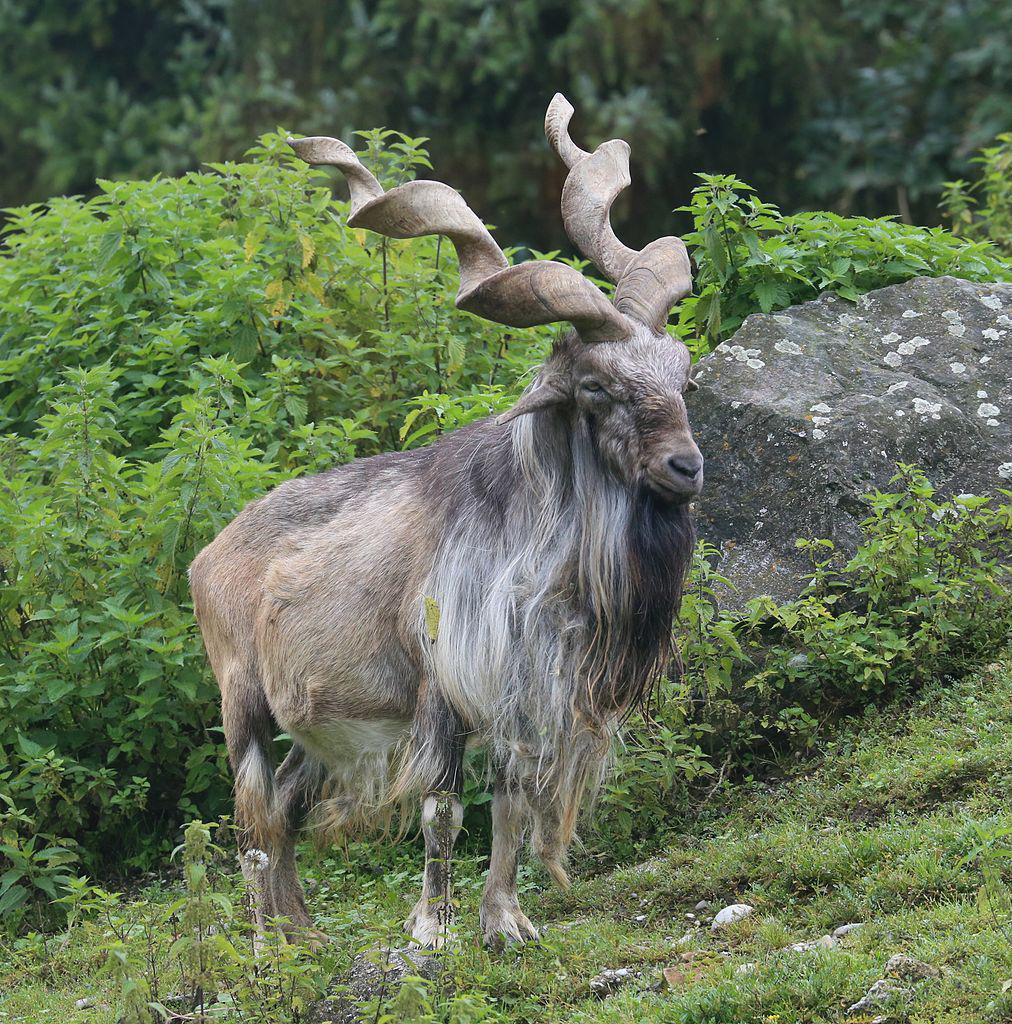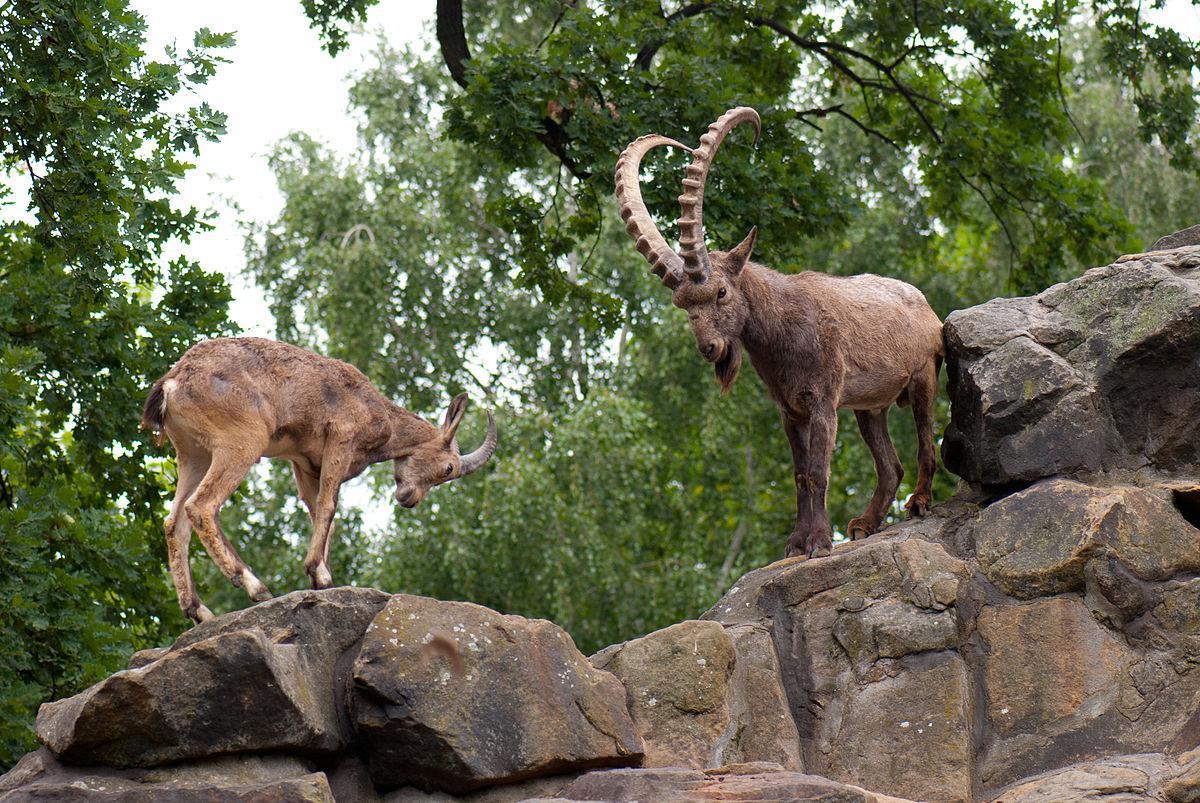The first image is the image on the left, the second image is the image on the right. Considering the images on both sides, is "The animals are facing the same way in both images of the pair." valid? Answer yes or no. No. 